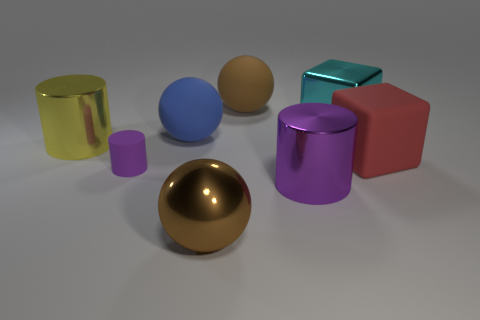What materials and colors are showcased in the objects within the image? The image displays a collection of objects with a variety of materials and colors. There's a shiny yellow-green cylindrical object that appears metallic, a purple cylindrical object with a metallic sheen, a red matte cube, a teal cube with a reflective surface suggesting a metallic or plastic material, a large matte blue sphere, and a smaller lavender cylinder with a dull finish. Lastly, there's a gold sphere with a reflective surface in the foreground. 